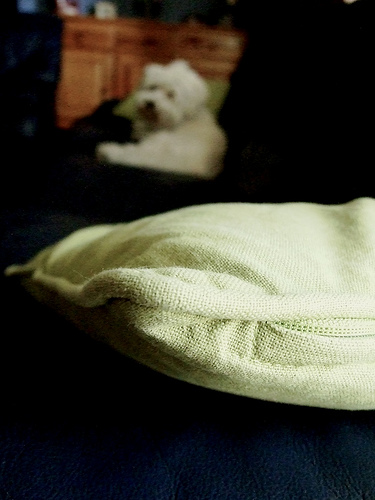<image>
Is the dog on the pillow? No. The dog is not positioned on the pillow. They may be near each other, but the dog is not supported by or resting on top of the pillow. 